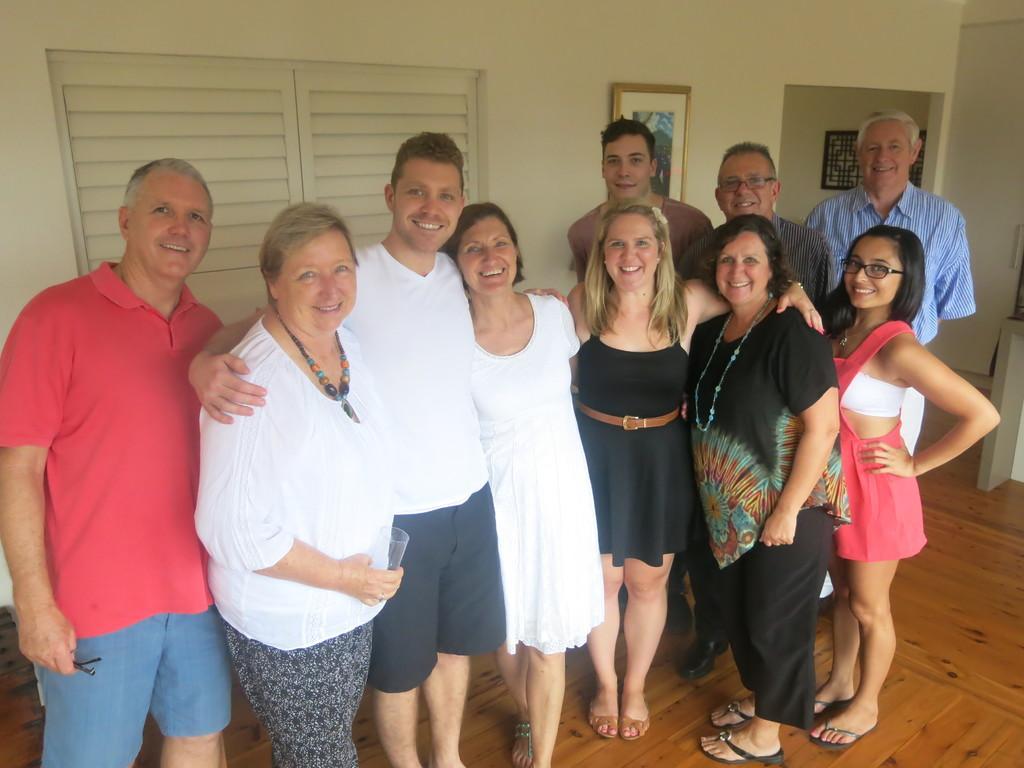Can you describe this image briefly? There are persons in different color dresses, smiling and standing on a floor. In the background, there is a photo frame attached to a wall which is having a window. 